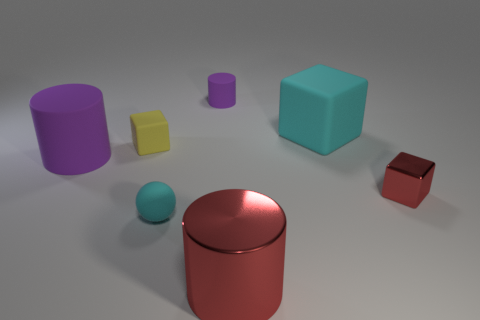Subtract all shiny cylinders. How many cylinders are left? 2 Subtract all yellow balls. How many purple cylinders are left? 2 Add 2 small purple objects. How many objects exist? 9 Subtract all spheres. How many objects are left? 6 Subtract 2 cubes. How many cubes are left? 1 Subtract all red cylinders. Subtract all cyan blocks. How many cylinders are left? 2 Subtract all metallic blocks. Subtract all cyan balls. How many objects are left? 5 Add 2 rubber spheres. How many rubber spheres are left? 3 Add 2 big gray matte cylinders. How many big gray matte cylinders exist? 2 Subtract 0 red balls. How many objects are left? 7 